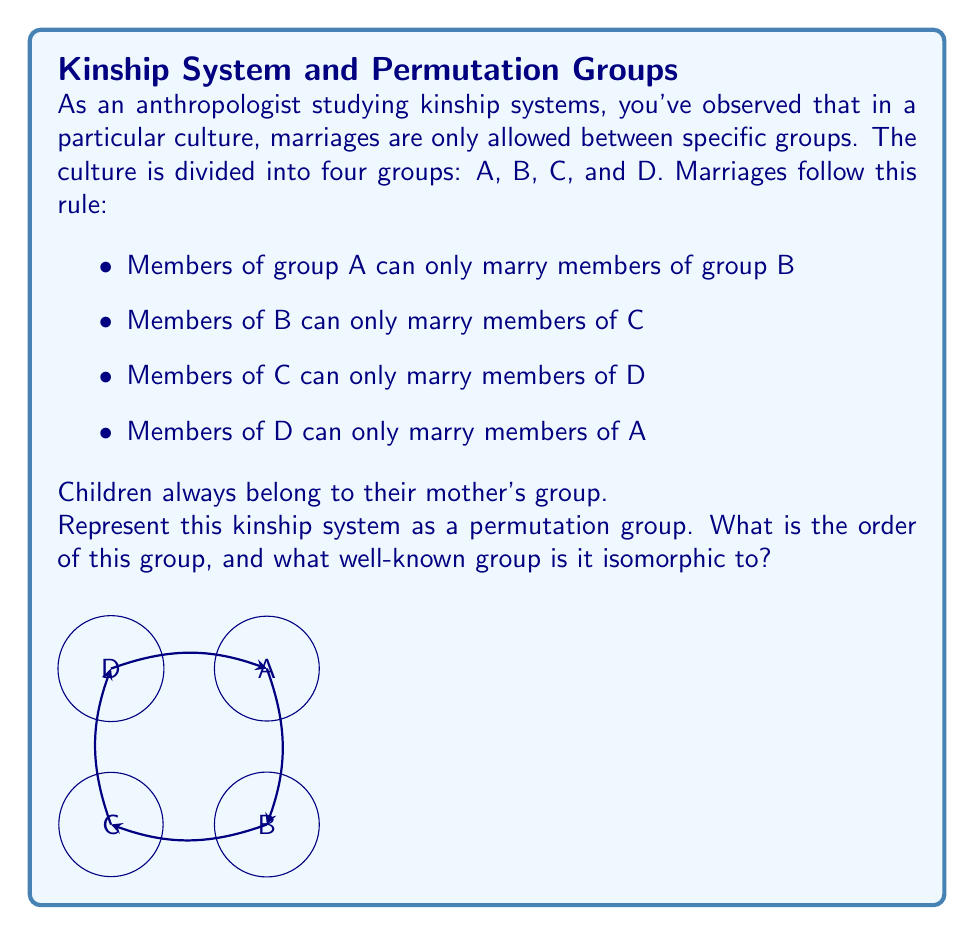Can you solve this math problem? Let's approach this step-by-step:

1) First, we need to understand how this system works as a permutation. When a person from group A marries someone from group B, their child will be in group B (mother's group). This means A is mapped to B.

2) Similarly, B maps to C, C maps to D, and D maps to A.

3) We can represent this as a permutation in cycle notation: $(ABCD)$

4) To find the order of this group, we need to see how many times we need to apply this permutation to get back to the identity permutation.
   $(ABCD)^1 = (ABCD)$
   $(ABCD)^2 = (ACBD)$
   $(ABCD)^3 = (ADBC)$
   $(ABCD)^4 = (AAAA) = e$ (identity)

5) Therefore, the order of this group is 4.

6) This group has the following properties:
   - It is cyclic (generated by a single element)
   - It has order 4
   - Each element (except identity) has order 4

7) These properties are characteristic of the cyclic group of order 4, denoted as $C_4$ or $\mathbb{Z}_4$.

Therefore, this kinship system is isomorphic to the cyclic group $C_4$ or $\mathbb{Z}_4$.
Answer: Order 4, isomorphic to $C_4$ (or $\mathbb{Z}_4$) 